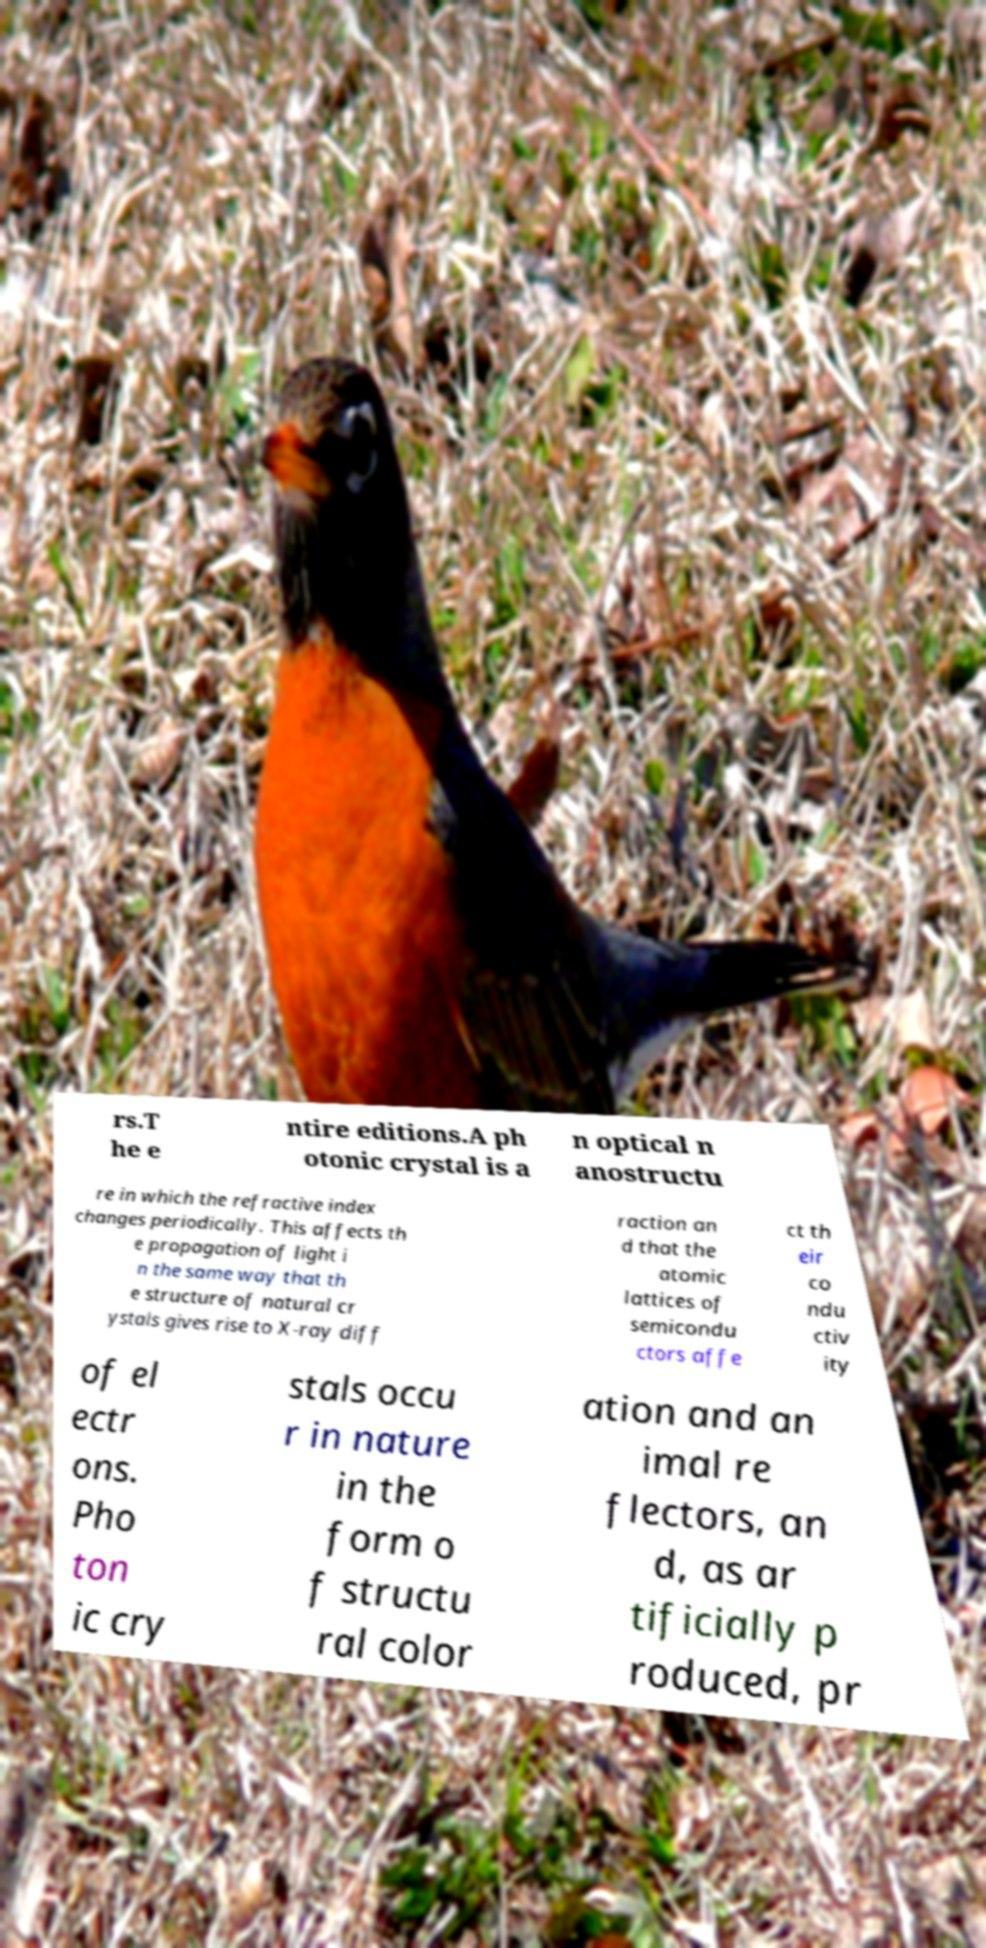Could you assist in decoding the text presented in this image and type it out clearly? rs.T he e ntire editions.A ph otonic crystal is a n optical n anostructu re in which the refractive index changes periodically. This affects th e propagation of light i n the same way that th e structure of natural cr ystals gives rise to X-ray diff raction an d that the atomic lattices of semicondu ctors affe ct th eir co ndu ctiv ity of el ectr ons. Pho ton ic cry stals occu r in nature in the form o f structu ral color ation and an imal re flectors, an d, as ar tificially p roduced, pr 